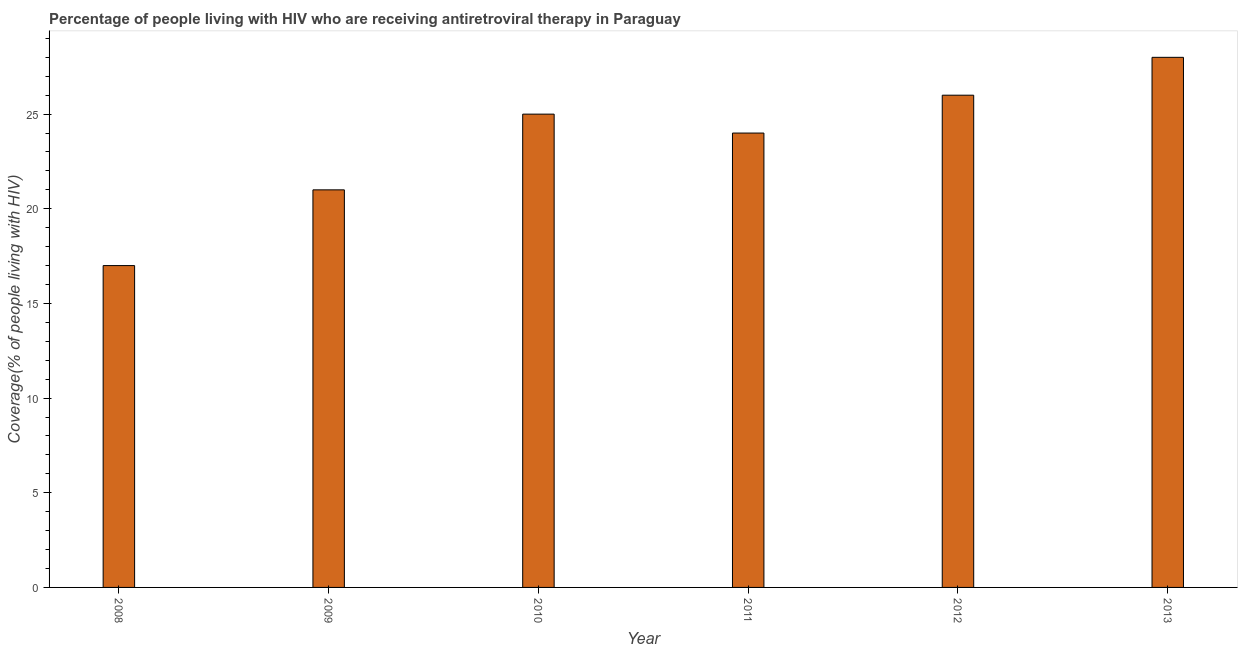Does the graph contain any zero values?
Give a very brief answer. No. Does the graph contain grids?
Keep it short and to the point. No. What is the title of the graph?
Ensure brevity in your answer.  Percentage of people living with HIV who are receiving antiretroviral therapy in Paraguay. What is the label or title of the X-axis?
Keep it short and to the point. Year. What is the label or title of the Y-axis?
Ensure brevity in your answer.  Coverage(% of people living with HIV). Across all years, what is the minimum antiretroviral therapy coverage?
Your answer should be very brief. 17. In which year was the antiretroviral therapy coverage maximum?
Your response must be concise. 2013. In which year was the antiretroviral therapy coverage minimum?
Offer a terse response. 2008. What is the sum of the antiretroviral therapy coverage?
Provide a succinct answer. 141. What is the difference between the antiretroviral therapy coverage in 2008 and 2012?
Offer a terse response. -9. What is the average antiretroviral therapy coverage per year?
Provide a short and direct response. 23. What is the median antiretroviral therapy coverage?
Give a very brief answer. 24.5. In how many years, is the antiretroviral therapy coverage greater than 27 %?
Make the answer very short. 1. Do a majority of the years between 2013 and 2012 (inclusive) have antiretroviral therapy coverage greater than 17 %?
Provide a succinct answer. No. What is the ratio of the antiretroviral therapy coverage in 2009 to that in 2012?
Your response must be concise. 0.81. Is the antiretroviral therapy coverage in 2009 less than that in 2011?
Give a very brief answer. Yes. Is the difference between the antiretroviral therapy coverage in 2009 and 2011 greater than the difference between any two years?
Provide a short and direct response. No. Is the sum of the antiretroviral therapy coverage in 2009 and 2010 greater than the maximum antiretroviral therapy coverage across all years?
Offer a terse response. Yes. How many bars are there?
Offer a very short reply. 6. Are all the bars in the graph horizontal?
Ensure brevity in your answer.  No. How many years are there in the graph?
Provide a succinct answer. 6. Are the values on the major ticks of Y-axis written in scientific E-notation?
Your response must be concise. No. What is the Coverage(% of people living with HIV) of 2008?
Your response must be concise. 17. What is the Coverage(% of people living with HIV) of 2010?
Offer a terse response. 25. What is the Coverage(% of people living with HIV) in 2012?
Offer a terse response. 26. What is the Coverage(% of people living with HIV) of 2013?
Offer a terse response. 28. What is the difference between the Coverage(% of people living with HIV) in 2008 and 2012?
Provide a succinct answer. -9. What is the difference between the Coverage(% of people living with HIV) in 2009 and 2010?
Provide a succinct answer. -4. What is the difference between the Coverage(% of people living with HIV) in 2009 and 2011?
Make the answer very short. -3. What is the difference between the Coverage(% of people living with HIV) in 2009 and 2012?
Offer a very short reply. -5. What is the difference between the Coverage(% of people living with HIV) in 2012 and 2013?
Your response must be concise. -2. What is the ratio of the Coverage(% of people living with HIV) in 2008 to that in 2009?
Your answer should be compact. 0.81. What is the ratio of the Coverage(% of people living with HIV) in 2008 to that in 2010?
Ensure brevity in your answer.  0.68. What is the ratio of the Coverage(% of people living with HIV) in 2008 to that in 2011?
Your answer should be compact. 0.71. What is the ratio of the Coverage(% of people living with HIV) in 2008 to that in 2012?
Provide a succinct answer. 0.65. What is the ratio of the Coverage(% of people living with HIV) in 2008 to that in 2013?
Provide a succinct answer. 0.61. What is the ratio of the Coverage(% of people living with HIV) in 2009 to that in 2010?
Offer a terse response. 0.84. What is the ratio of the Coverage(% of people living with HIV) in 2009 to that in 2011?
Give a very brief answer. 0.88. What is the ratio of the Coverage(% of people living with HIV) in 2009 to that in 2012?
Your answer should be compact. 0.81. What is the ratio of the Coverage(% of people living with HIV) in 2010 to that in 2011?
Offer a terse response. 1.04. What is the ratio of the Coverage(% of people living with HIV) in 2010 to that in 2013?
Your answer should be very brief. 0.89. What is the ratio of the Coverage(% of people living with HIV) in 2011 to that in 2012?
Your answer should be compact. 0.92. What is the ratio of the Coverage(% of people living with HIV) in 2011 to that in 2013?
Offer a very short reply. 0.86. What is the ratio of the Coverage(% of people living with HIV) in 2012 to that in 2013?
Offer a very short reply. 0.93. 